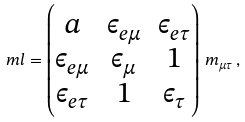Convert formula to latex. <formula><loc_0><loc_0><loc_500><loc_500>\ m l = \begin{pmatrix} a & \epsilon _ { e \mu } & \epsilon _ { e \tau } \\ \epsilon _ { e \mu } & \epsilon _ { \mu } & 1 \\ \epsilon _ { e \tau } & 1 & \epsilon _ { \tau } \end{pmatrix} \, m _ { \mu \tau } \, ,</formula> 